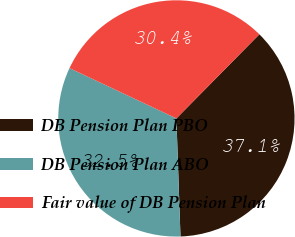Convert chart. <chart><loc_0><loc_0><loc_500><loc_500><pie_chart><fcel>DB Pension Plan PBO<fcel>DB Pension Plan ABO<fcel>Fair value of DB Pension Plan<nl><fcel>37.06%<fcel>32.55%<fcel>30.39%<nl></chart> 